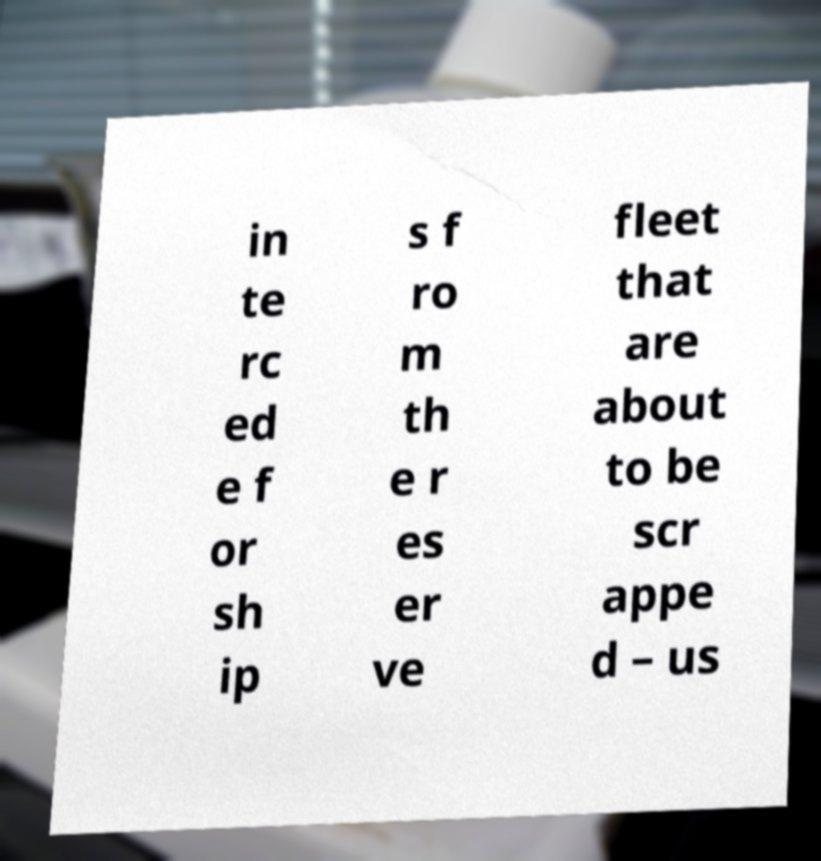Can you read and provide the text displayed in the image?This photo seems to have some interesting text. Can you extract and type it out for me? in te rc ed e f or sh ip s f ro m th e r es er ve fleet that are about to be scr appe d – us 